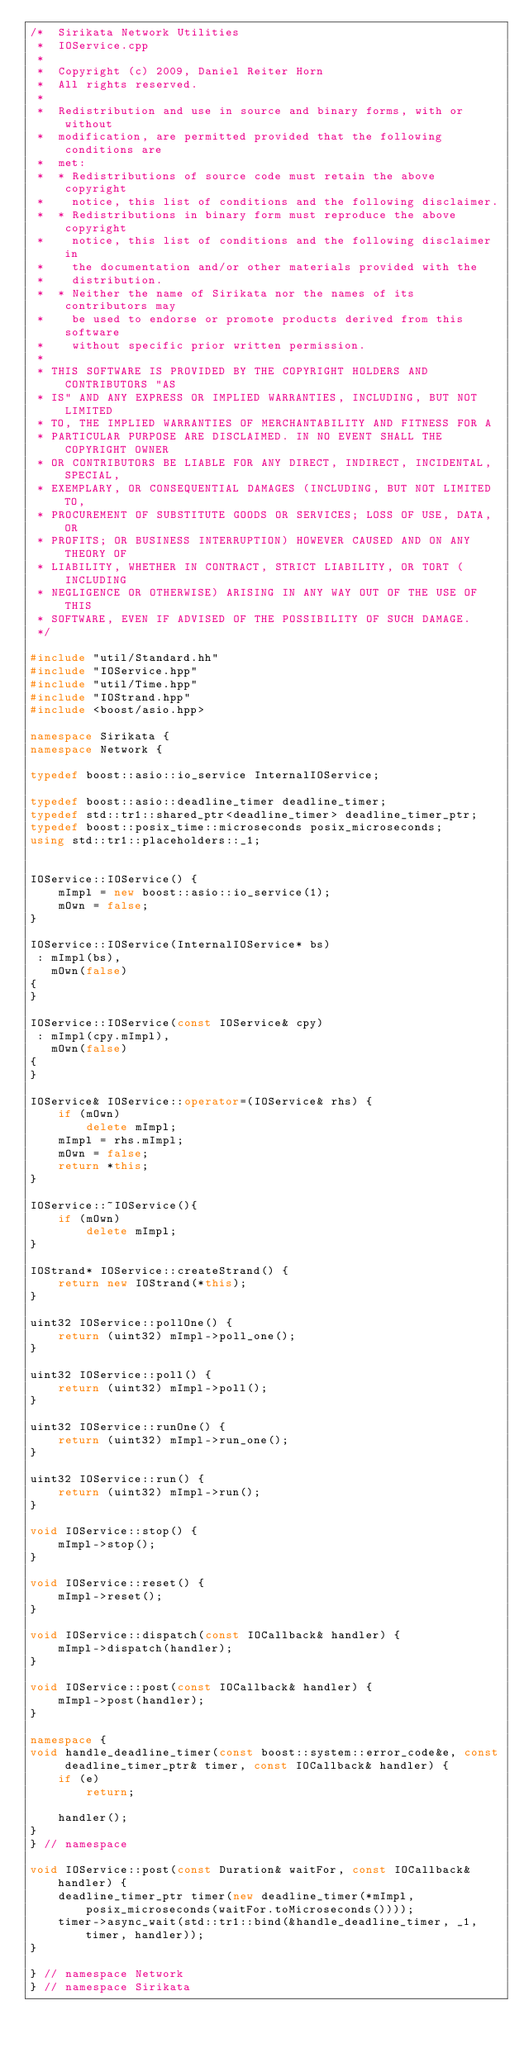Convert code to text. <code><loc_0><loc_0><loc_500><loc_500><_C++_>/*  Sirikata Network Utilities
 *  IOService.cpp
 *
 *  Copyright (c) 2009, Daniel Reiter Horn
 *  All rights reserved.
 *
 *  Redistribution and use in source and binary forms, with or without
 *  modification, are permitted provided that the following conditions are
 *  met:
 *  * Redistributions of source code must retain the above copyright
 *    notice, this list of conditions and the following disclaimer.
 *  * Redistributions in binary form must reproduce the above copyright
 *    notice, this list of conditions and the following disclaimer in
 *    the documentation and/or other materials provided with the
 *    distribution.
 *  * Neither the name of Sirikata nor the names of its contributors may
 *    be used to endorse or promote products derived from this software
 *    without specific prior written permission.
 *
 * THIS SOFTWARE IS PROVIDED BY THE COPYRIGHT HOLDERS AND CONTRIBUTORS "AS
 * IS" AND ANY EXPRESS OR IMPLIED WARRANTIES, INCLUDING, BUT NOT LIMITED
 * TO, THE IMPLIED WARRANTIES OF MERCHANTABILITY AND FITNESS FOR A
 * PARTICULAR PURPOSE ARE DISCLAIMED. IN NO EVENT SHALL THE COPYRIGHT OWNER
 * OR CONTRIBUTORS BE LIABLE FOR ANY DIRECT, INDIRECT, INCIDENTAL, SPECIAL,
 * EXEMPLARY, OR CONSEQUENTIAL DAMAGES (INCLUDING, BUT NOT LIMITED TO,
 * PROCUREMENT OF SUBSTITUTE GOODS OR SERVICES; LOSS OF USE, DATA, OR
 * PROFITS; OR BUSINESS INTERRUPTION) HOWEVER CAUSED AND ON ANY THEORY OF
 * LIABILITY, WHETHER IN CONTRACT, STRICT LIABILITY, OR TORT (INCLUDING
 * NEGLIGENCE OR OTHERWISE) ARISING IN ANY WAY OUT OF THE USE OF THIS
 * SOFTWARE, EVEN IF ADVISED OF THE POSSIBILITY OF SUCH DAMAGE.
 */

#include "util/Standard.hh"
#include "IOService.hpp"
#include "util/Time.hpp"
#include "IOStrand.hpp"
#include <boost/asio.hpp>

namespace Sirikata {
namespace Network {

typedef boost::asio::io_service InternalIOService;

typedef boost::asio::deadline_timer deadline_timer;
typedef std::tr1::shared_ptr<deadline_timer> deadline_timer_ptr;
typedef boost::posix_time::microseconds posix_microseconds;
using std::tr1::placeholders::_1;


IOService::IOService() {
    mImpl = new boost::asio::io_service(1);
    mOwn = false;
}

IOService::IOService(InternalIOService* bs)
 : mImpl(bs),
   mOwn(false)
{
}

IOService::IOService(const IOService& cpy)
 : mImpl(cpy.mImpl),
   mOwn(false)
{
}

IOService& IOService::operator=(IOService& rhs) {
    if (mOwn)
        delete mImpl;
    mImpl = rhs.mImpl;
    mOwn = false;
    return *this;
}

IOService::~IOService(){
    if (mOwn)
        delete mImpl;
}

IOStrand* IOService::createStrand() {
    return new IOStrand(*this);
}

uint32 IOService::pollOne() {
    return (uint32) mImpl->poll_one();
}

uint32 IOService::poll() {
    return (uint32) mImpl->poll();
}

uint32 IOService::runOne() {
    return (uint32) mImpl->run_one();
}

uint32 IOService::run() {
    return (uint32) mImpl->run();
}

void IOService::stop() {
    mImpl->stop();
}

void IOService::reset() {
    mImpl->reset();
}

void IOService::dispatch(const IOCallback& handler) {
    mImpl->dispatch(handler);
}

void IOService::post(const IOCallback& handler) {
    mImpl->post(handler);
}

namespace {
void handle_deadline_timer(const boost::system::error_code&e, const deadline_timer_ptr& timer, const IOCallback& handler) {
    if (e)
        return;

    handler();
}
} // namespace

void IOService::post(const Duration& waitFor, const IOCallback& handler) {
    deadline_timer_ptr timer(new deadline_timer(*mImpl, posix_microseconds(waitFor.toMicroseconds())));
    timer->async_wait(std::tr1::bind(&handle_deadline_timer, _1, timer, handler));
}

} // namespace Network
} // namespace Sirikata
</code> 